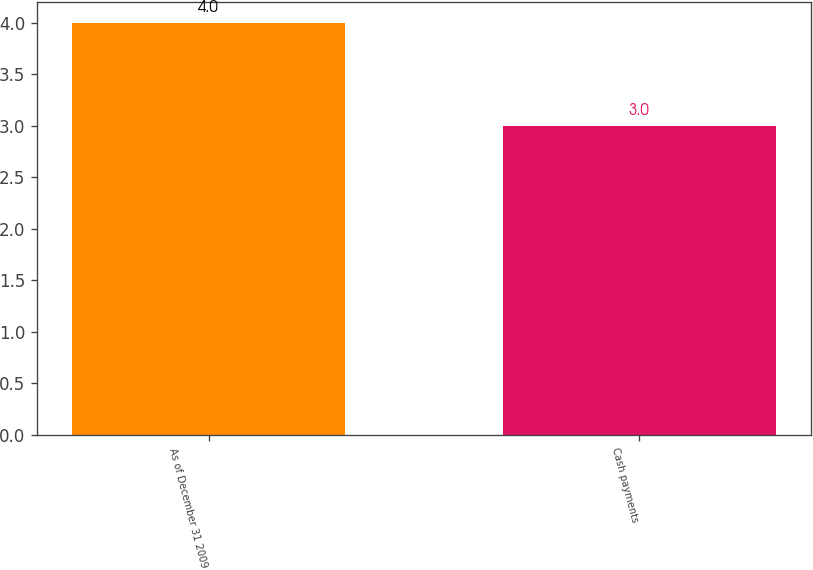<chart> <loc_0><loc_0><loc_500><loc_500><bar_chart><fcel>As of December 31 2009<fcel>Cash payments<nl><fcel>4<fcel>3<nl></chart> 